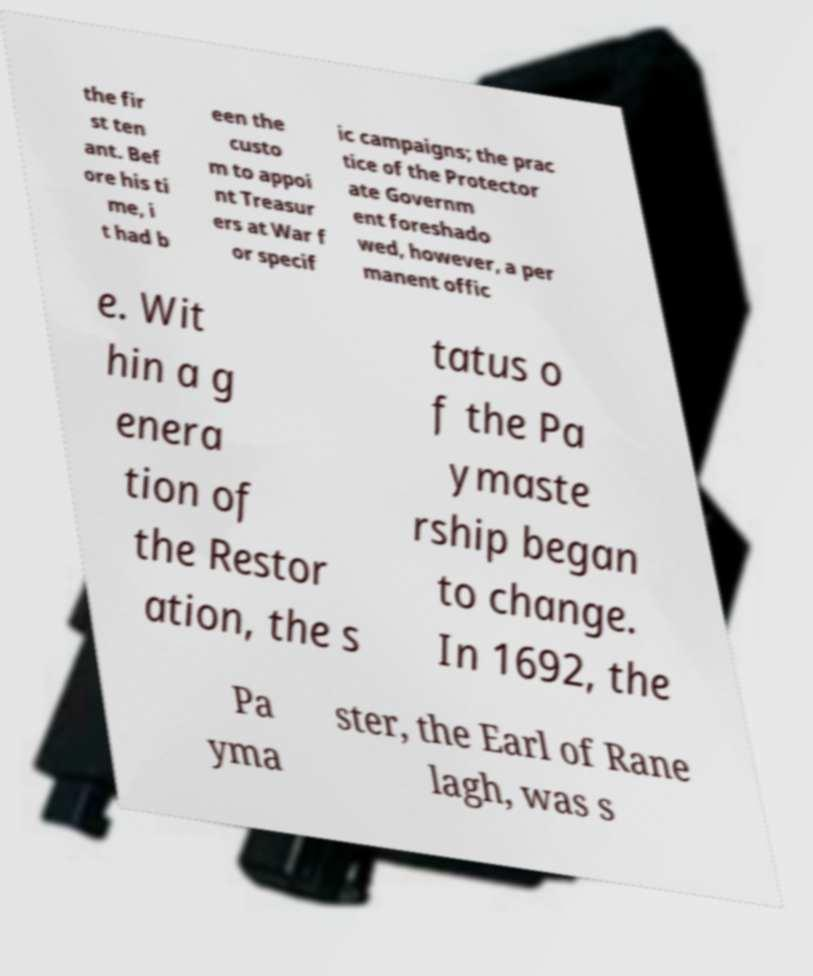There's text embedded in this image that I need extracted. Can you transcribe it verbatim? the fir st ten ant. Bef ore his ti me, i t had b een the custo m to appoi nt Treasur ers at War f or specif ic campaigns; the prac tice of the Protector ate Governm ent foreshado wed, however, a per manent offic e. Wit hin a g enera tion of the Restor ation, the s tatus o f the Pa ymaste rship began to change. In 1692, the Pa yma ster, the Earl of Rane lagh, was s 